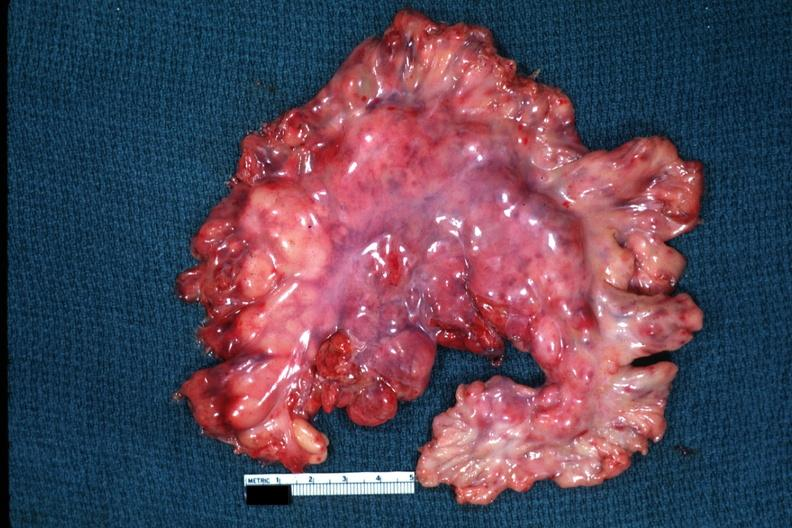s mesentery present?
Answer the question using a single word or phrase. Yes 